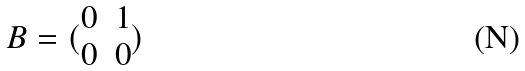<formula> <loc_0><loc_0><loc_500><loc_500>B = ( \begin{matrix} 0 & 1 \\ 0 & 0 \end{matrix} )</formula> 